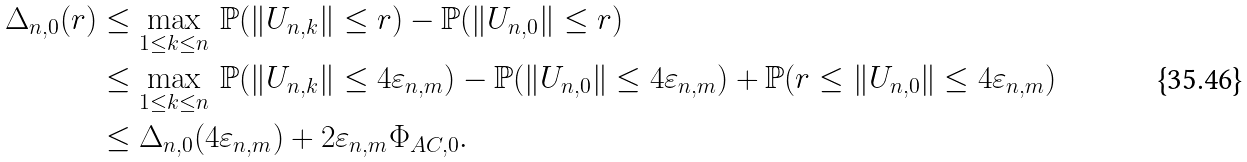Convert formula to latex. <formula><loc_0><loc_0><loc_500><loc_500>\Delta _ { n , 0 } ( r ) & \leq \max _ { 1 \leq k \leq n } \, \mathbb { P } ( \| U _ { n , k } \| \leq r ) - \mathbb { P } ( \| U _ { n , 0 } \| \leq r ) \\ & \leq \max _ { 1 \leq k \leq n } \, \mathbb { P } ( \| U _ { n , k } \| \leq 4 \varepsilon _ { n , m } ) - \mathbb { P } ( \| U _ { n , 0 } \| \leq 4 \varepsilon _ { n , m } ) + \mathbb { P } ( r \leq \| U _ { n , 0 } \| \leq 4 \varepsilon _ { n , m } ) \\ & \leq \Delta _ { n , 0 } ( 4 \varepsilon _ { n , m } ) + 2 \varepsilon _ { n , m } \Phi _ { A C , 0 } .</formula> 